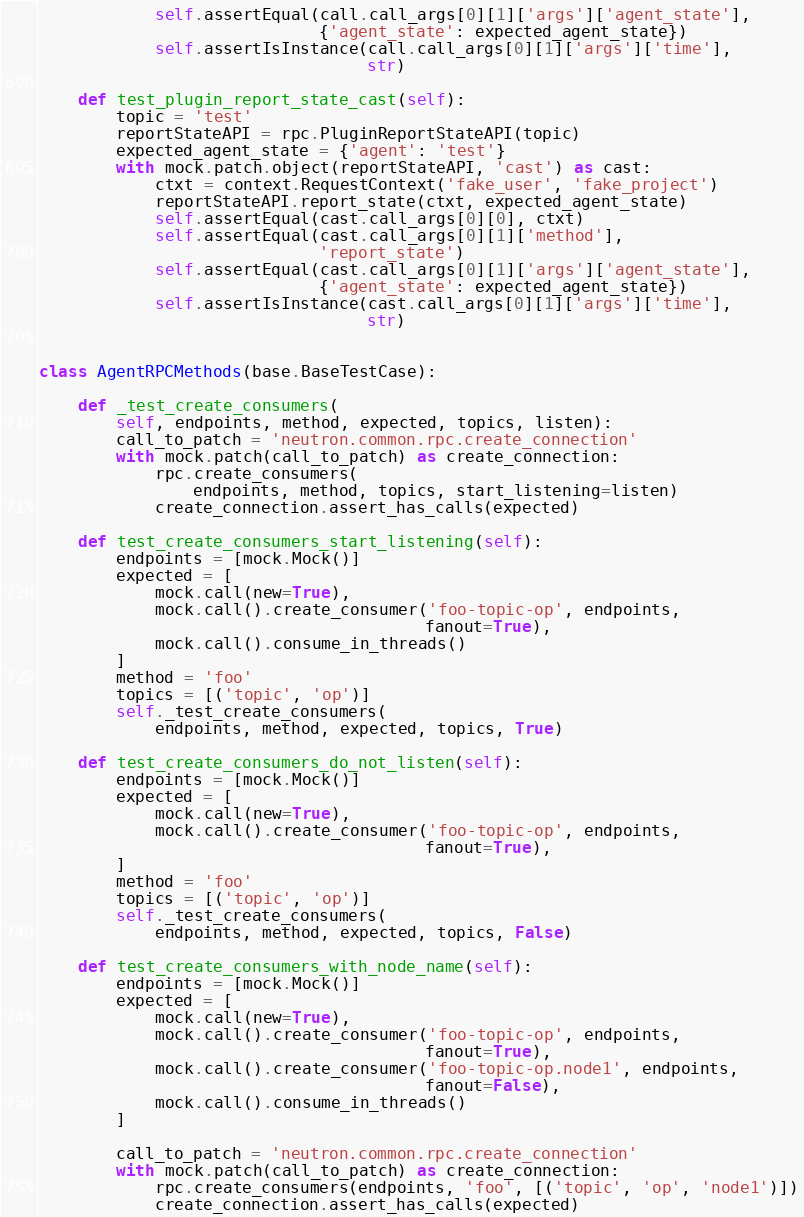Convert code to text. <code><loc_0><loc_0><loc_500><loc_500><_Python_>            self.assertEqual(call.call_args[0][1]['args']['agent_state'],
                             {'agent_state': expected_agent_state})
            self.assertIsInstance(call.call_args[0][1]['args']['time'],
                                  str)

    def test_plugin_report_state_cast(self):
        topic = 'test'
        reportStateAPI = rpc.PluginReportStateAPI(topic)
        expected_agent_state = {'agent': 'test'}
        with mock.patch.object(reportStateAPI, 'cast') as cast:
            ctxt = context.RequestContext('fake_user', 'fake_project')
            reportStateAPI.report_state(ctxt, expected_agent_state)
            self.assertEqual(cast.call_args[0][0], ctxt)
            self.assertEqual(cast.call_args[0][1]['method'],
                             'report_state')
            self.assertEqual(cast.call_args[0][1]['args']['agent_state'],
                             {'agent_state': expected_agent_state})
            self.assertIsInstance(cast.call_args[0][1]['args']['time'],
                                  str)


class AgentRPCMethods(base.BaseTestCase):

    def _test_create_consumers(
        self, endpoints, method, expected, topics, listen):
        call_to_patch = 'neutron.common.rpc.create_connection'
        with mock.patch(call_to_patch) as create_connection:
            rpc.create_consumers(
                endpoints, method, topics, start_listening=listen)
            create_connection.assert_has_calls(expected)

    def test_create_consumers_start_listening(self):
        endpoints = [mock.Mock()]
        expected = [
            mock.call(new=True),
            mock.call().create_consumer('foo-topic-op', endpoints,
                                        fanout=True),
            mock.call().consume_in_threads()
        ]
        method = 'foo'
        topics = [('topic', 'op')]
        self._test_create_consumers(
            endpoints, method, expected, topics, True)

    def test_create_consumers_do_not_listen(self):
        endpoints = [mock.Mock()]
        expected = [
            mock.call(new=True),
            mock.call().create_consumer('foo-topic-op', endpoints,
                                        fanout=True),
        ]
        method = 'foo'
        topics = [('topic', 'op')]
        self._test_create_consumers(
            endpoints, method, expected, topics, False)

    def test_create_consumers_with_node_name(self):
        endpoints = [mock.Mock()]
        expected = [
            mock.call(new=True),
            mock.call().create_consumer('foo-topic-op', endpoints,
                                        fanout=True),
            mock.call().create_consumer('foo-topic-op.node1', endpoints,
                                        fanout=False),
            mock.call().consume_in_threads()
        ]

        call_to_patch = 'neutron.common.rpc.create_connection'
        with mock.patch(call_to_patch) as create_connection:
            rpc.create_consumers(endpoints, 'foo', [('topic', 'op', 'node1')])
            create_connection.assert_has_calls(expected)
</code> 